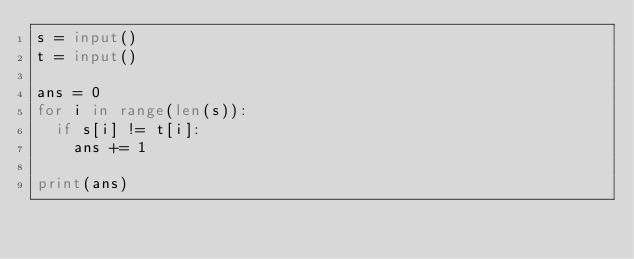<code> <loc_0><loc_0><loc_500><loc_500><_Python_>s = input()
t = input()

ans = 0
for i in range(len(s)):
  if s[i] != t[i]:
    ans += 1
    
print(ans)</code> 